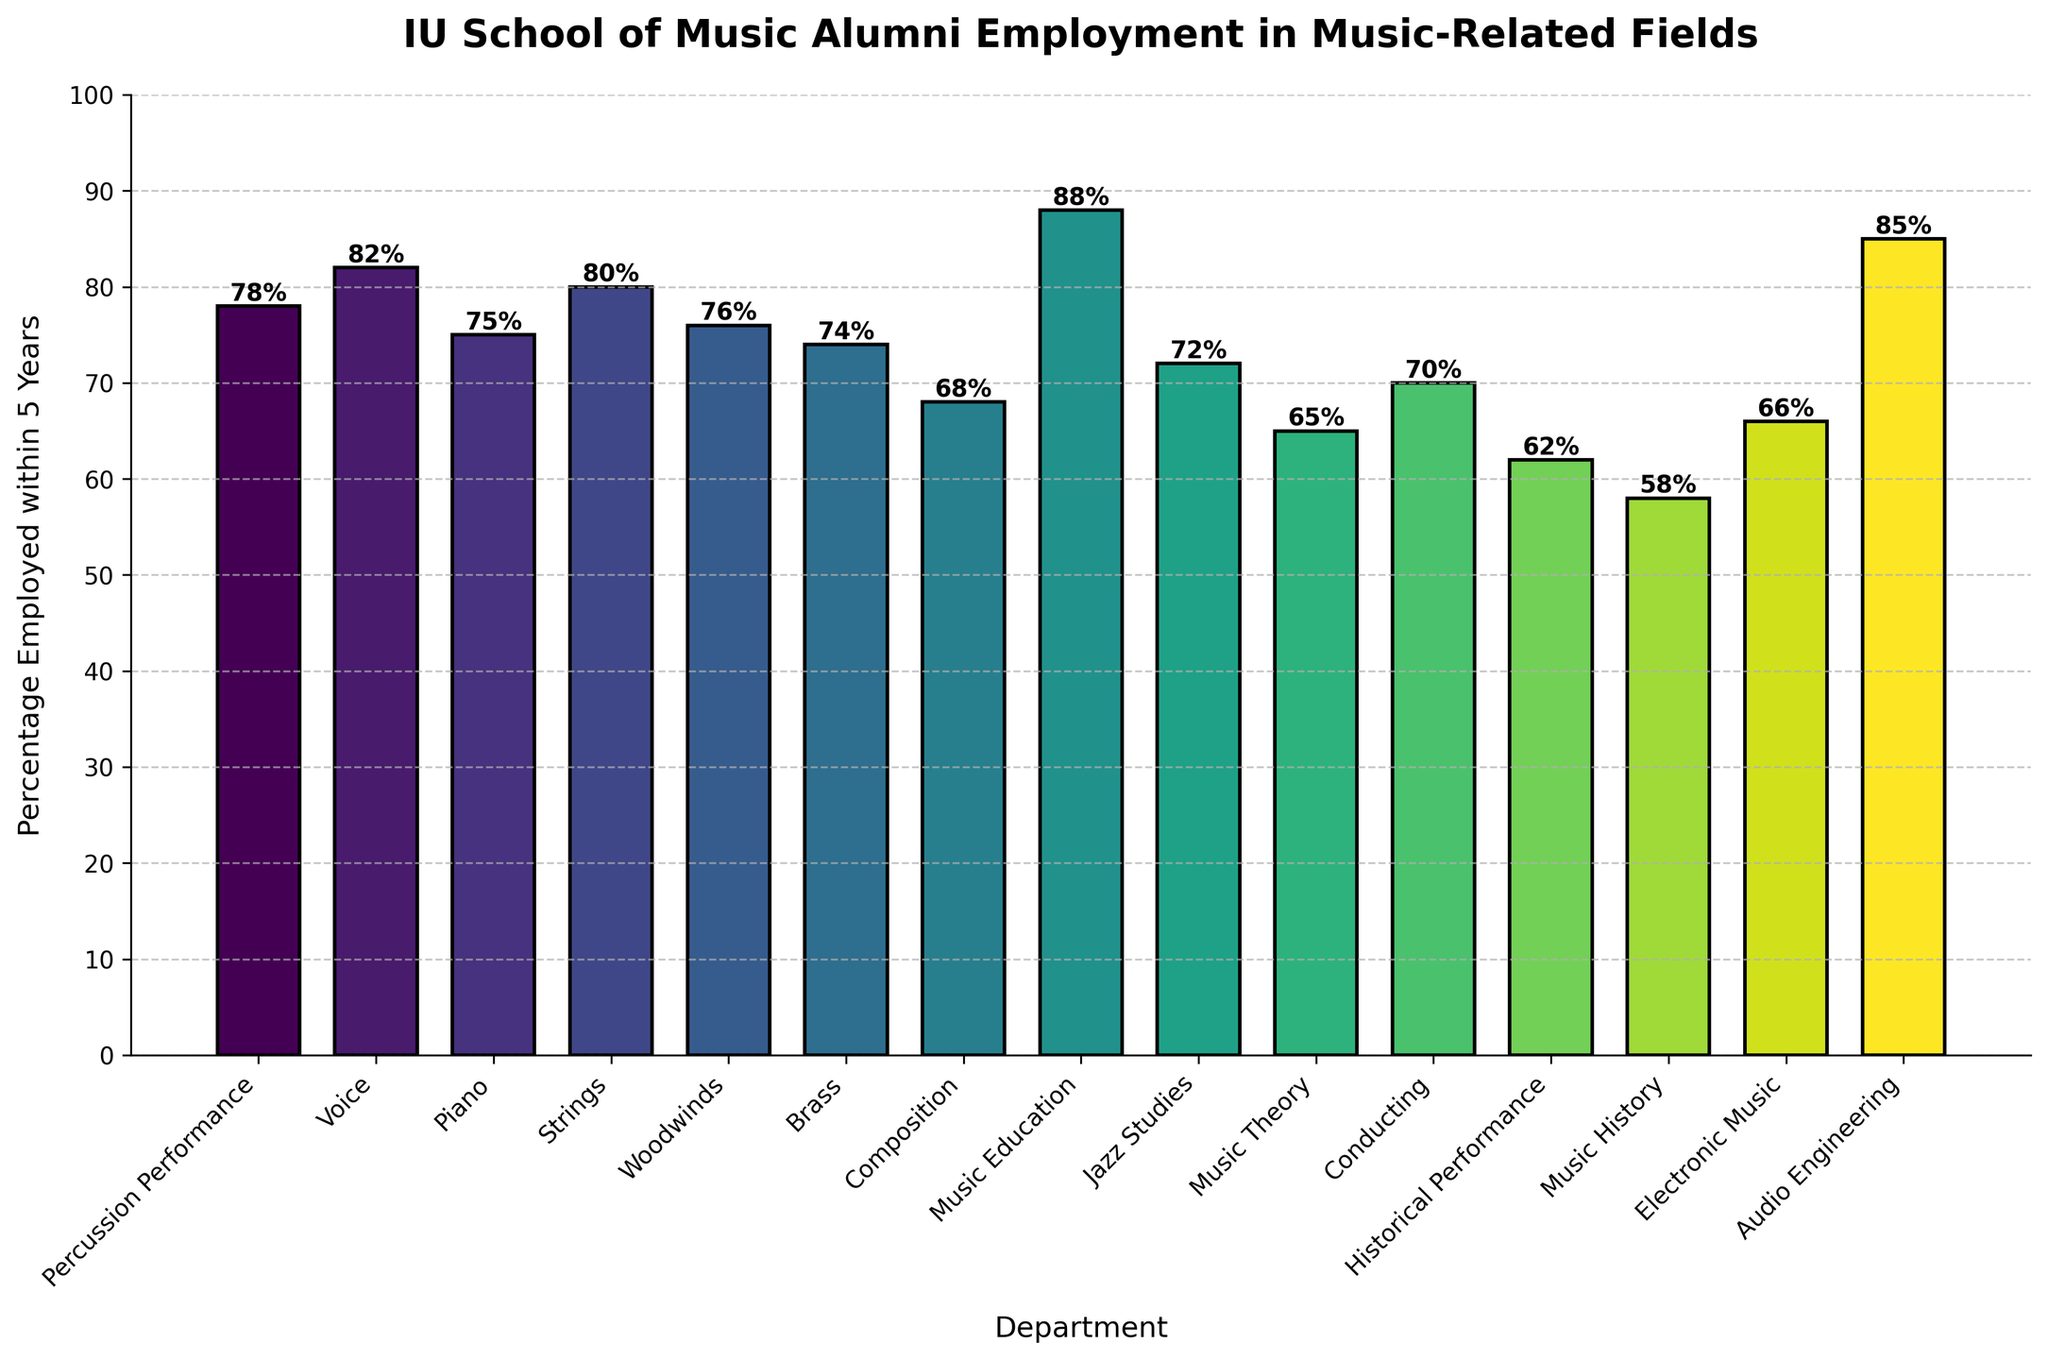Which department has the highest percentage of alumni employed in music-related fields within 5 years of graduation? To identify the department, look for the tallest bar in the chart. The Music Education department has the highest percentage.
Answer: Music Education What is the difference in employment percentage between the Composition and Audio Engineering departments? Subtract the percentage of Composition (68%) from the percentage of Audio Engineering (85%). The result is 85 - 68.
Answer: 17 Which departments have a higher percentage of alumni employment compared to Percussion Performance? Look for bars taller than the Percussion Performance bar (78%). The departments are Voice (82%), Strings (80%), Music Education (88%), and Audio Engineering (85%).
Answer: Voice, Strings, Music Education, Audio Engineering What is the average employment percentage of the Jazz Studies, Conducting, and Electronic Music departments? Add the percentages of Jazz Studies (72%), Conducting (70%), and Electronic Music (66%), then divide by 3. (72 + 70 + 66) / 3.
Answer: 69.33 How many departments have an employment percentage below 70%? Count the number of bars that do not reach the 70% mark. These are Composition (68%), Music Theory (65%), Historical Performance (62%), and Music History (58%).
Answer: 4 What is the total percentage of alumni employed in music-related fields for Voice and Piano departments combined? Add the percentages of Voice (82%) and Piano (75%). 82 + 75 = 157.
Answer: 157 Which department is the least employed in music-related fields? Look for the shortest bar in the chart, which represents the lowest employment percentage. Music History has the shortest bar at 58%.
Answer: Music History If the employment percentages for Percussion Performance and Woodwinds were to increase by 5%, what would their new percentages be? Add 5 to the original percentages of Percussion Performance (78%) and Woodwinds (76%). Percussion Performance: 78 + 5 = 83. Woodwinds: 76 + 5 = 81.
Answer: Percussion Performance: 83, Woodwinds: 81 What is the median employment percentage across all departments? Arrange the percentages in ascending order and find the middle value. The ordered list is: 58, 62, 65, 66, 68, 70, 72, 74, 75, 76, 78, 80, 82, 85, 88. The median value is the 8th element.
Answer: 74 How many departments have a percentage of 80% or higher? Count the bars that reach or exceed the 80% mark. These departments are Voice (82%), Strings (80%), Music Education (88%), and Audio Engineering (85%).
Answer: 4 